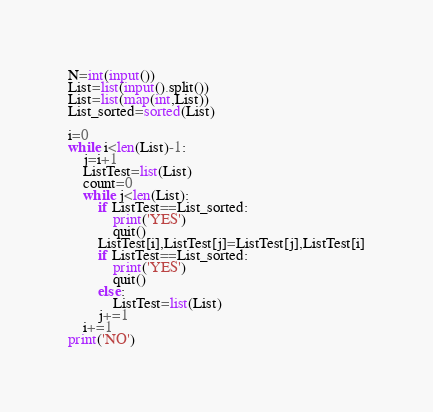Convert code to text. <code><loc_0><loc_0><loc_500><loc_500><_Python_>N=int(input())
List=list(input().split())
List=list(map(int,List))
List_sorted=sorted(List)

i=0
while i<len(List)-1:
    j=i+1
    ListTest=list(List)
    count=0
    while j<len(List):
        if ListTest==List_sorted:
            print('YES')
            quit()
        ListTest[i],ListTest[j]=ListTest[j],ListTest[i]
        if ListTest==List_sorted:
            print('YES')
            quit()
        else:
            ListTest=list(List)
        j+=1
    i+=1
print('NO')
</code> 